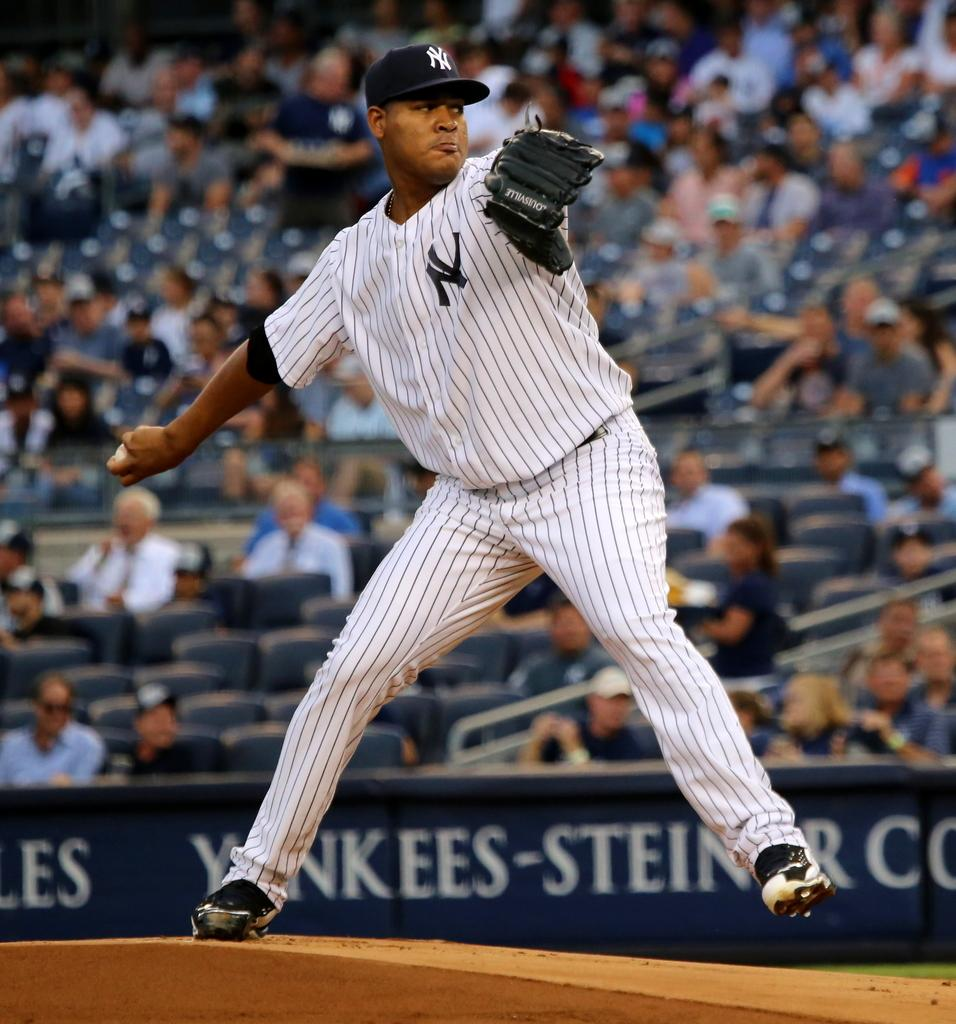<image>
Describe the image concisely. A New York Yankees pitcher standing on the mound winds up to make his throw. 